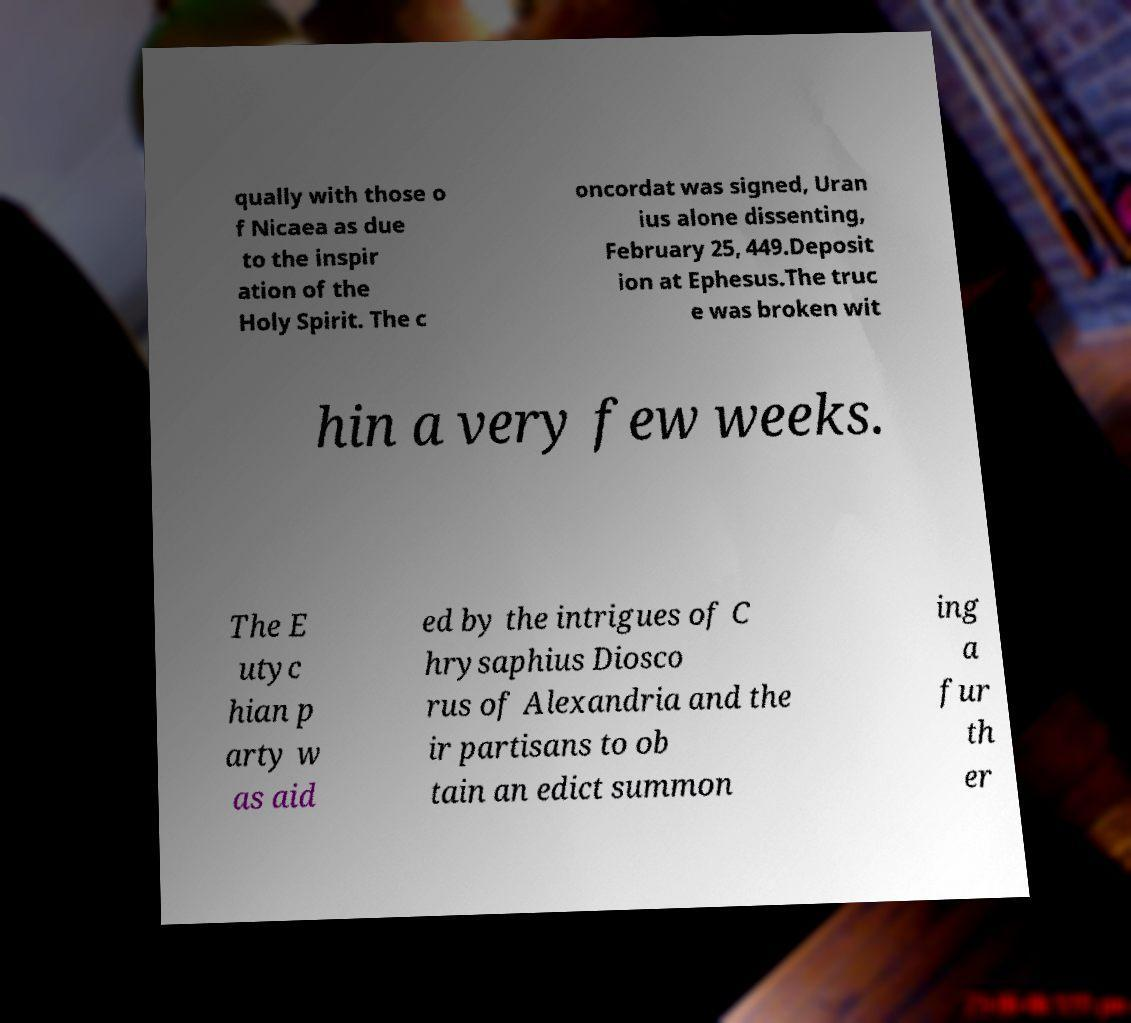Can you read and provide the text displayed in the image?This photo seems to have some interesting text. Can you extract and type it out for me? qually with those o f Nicaea as due to the inspir ation of the Holy Spirit. The c oncordat was signed, Uran ius alone dissenting, February 25, 449.Deposit ion at Ephesus.The truc e was broken wit hin a very few weeks. The E utyc hian p arty w as aid ed by the intrigues of C hrysaphius Diosco rus of Alexandria and the ir partisans to ob tain an edict summon ing a fur th er 